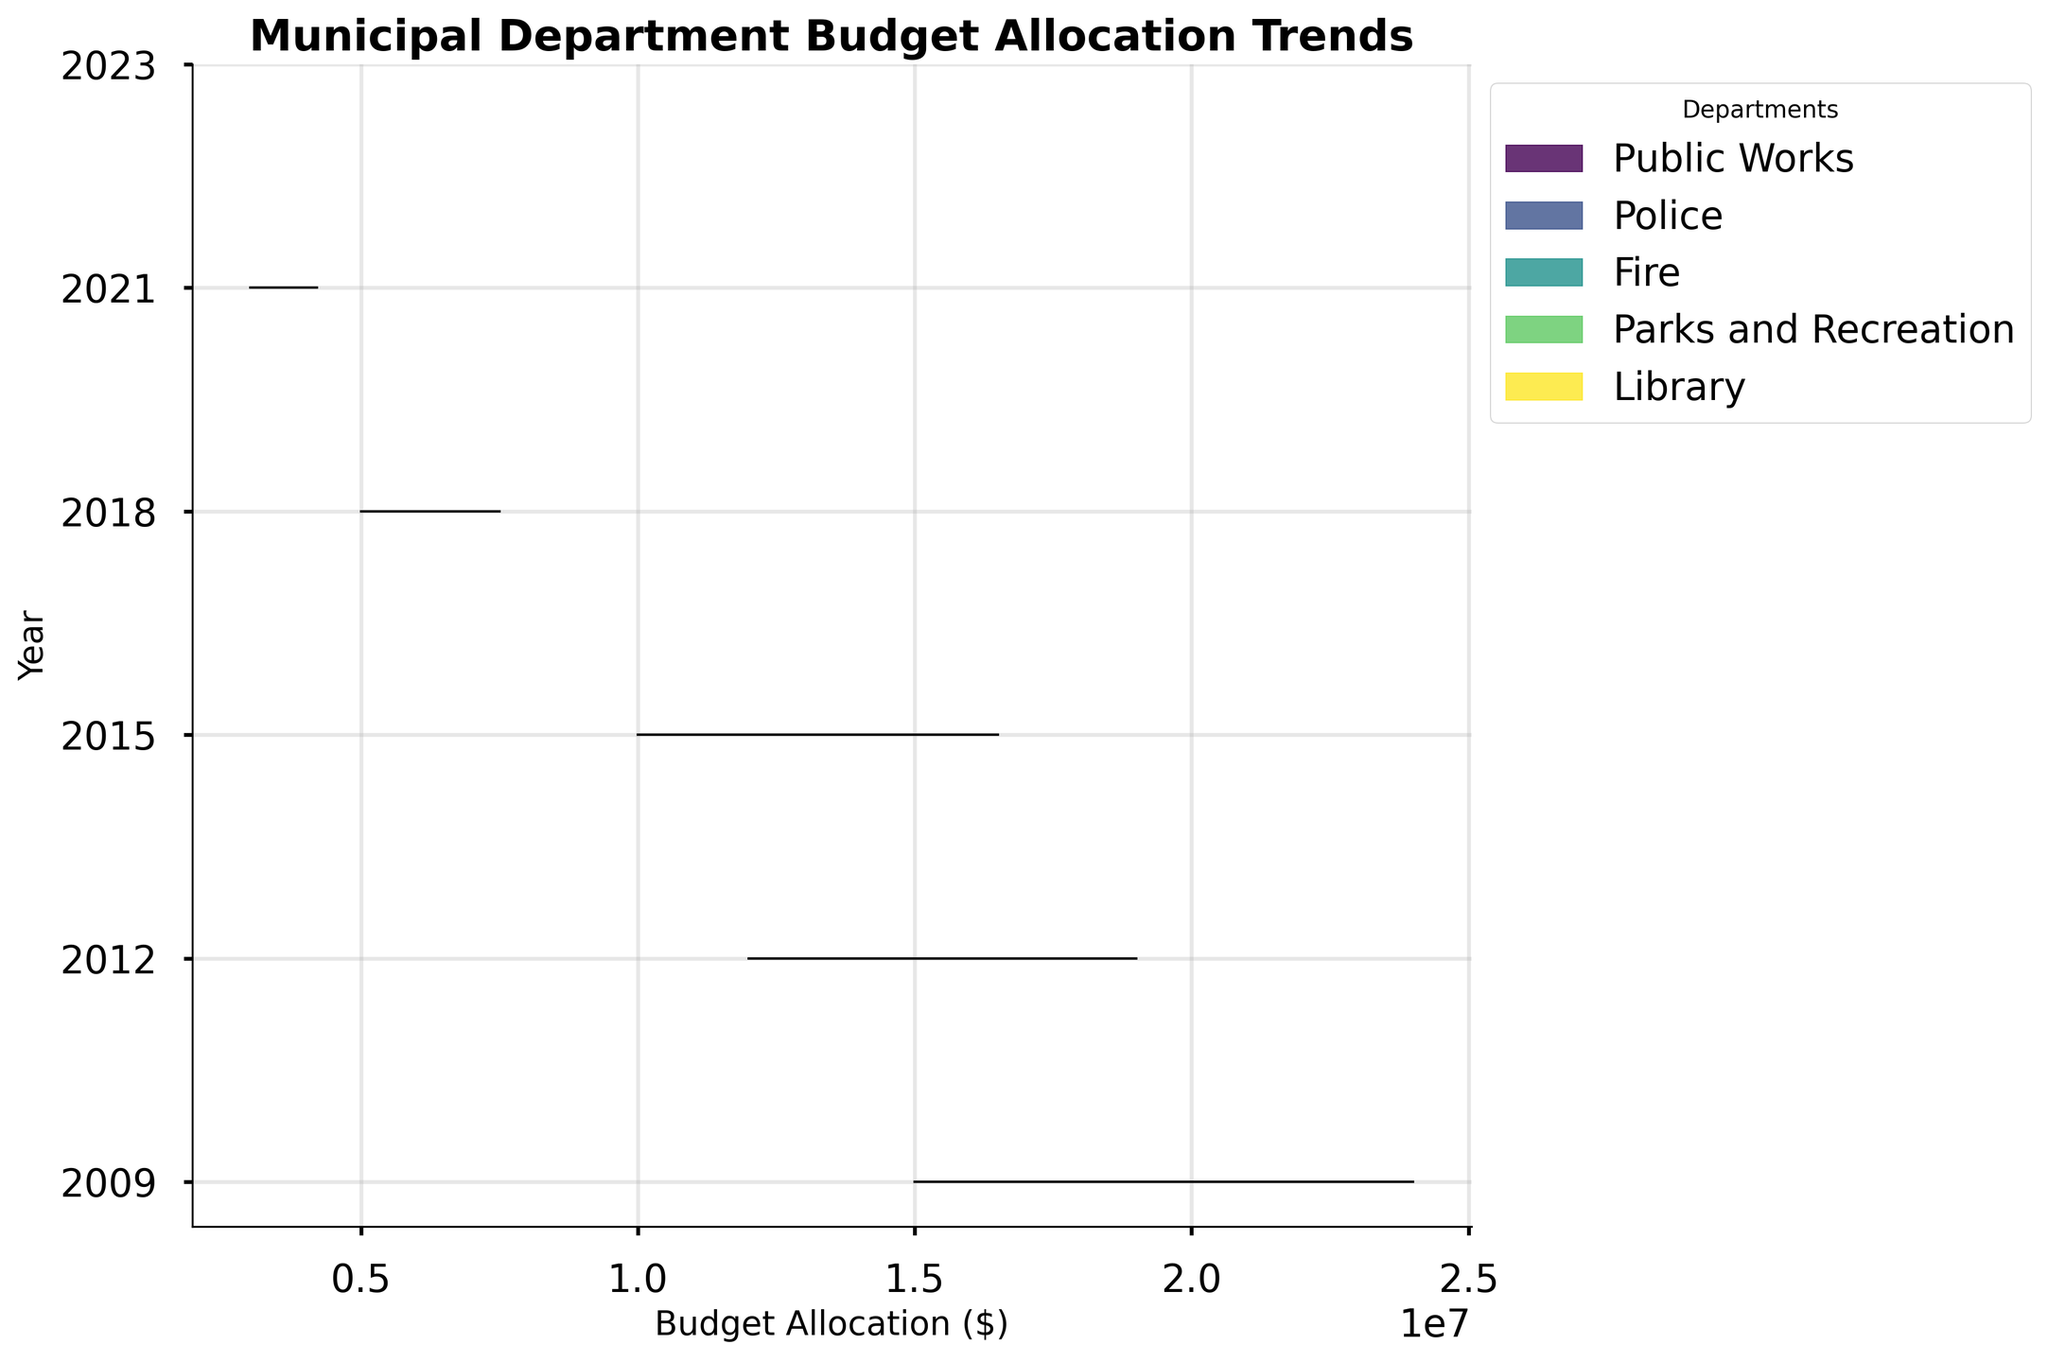What's the title of the figure? The title is usually found at the top of the plot, summarizing what the figure represents. By looking at the top of the figure, we can see the text displayed.
Answer: Municipal Department Budget Allocation Trends What do the colors in the plot represent? In ridgeline plots, colors are used to differentiate between different categories or groups. By checking the legend located typically on the side, we can see that colors represent various departments.
Answer: Different municipal departments Which department had the highest budget allocation in 2023? By examining the 2023 line and finding the peak value among the different colors representing each department, we can identify the department with the highest budget allocation.
Answer: Public Works Have any departments increased their budget allocation consistently over all years? Observing the trend lines for each department over the years, if a department's budget line never decreases but always increases or stays the same, it shows consistent growth.
Answer: Yes, Public Works Which department showed the least amount of change in budget allocation over the years? To find this, visually compare the peak variances for each department from one year to the next. The department with the smallest difference between its lowest and highest values over all years has the least change.
Answer: Library How does the budget allocation for Police in 2021 compare to that in 2015? Locate the Police department in the legend, then trace the peaks corresponding to 2015 and 2021 for the Police budget in the plot. Compare the height of the peaks.
Answer: It increased from 14500000 to 17500000 What is the general trend of budget allocation for the Fire department? Look at the peaks of the Fire department across all years. Observing their relative heights, we can discern whether they are generally rising, falling, or stable.
Answer: Increasing Which year had the smallest range of budget allocations across all departments? For each year, visually measure the distance between the lowest and highest budget allocation peaks. The year with the smallest visual distance has the smallest range.
Answer: 2009 What is the trend difference between Parks and Recreation and Library from 2015 to 2023? Compare the change in peaks for Parks and Recreation and Library between the years 2015 and 2023. Identify whether each increased, decreased, or remained stable and note the differences.
Answer: Parks and Recreation increased more than Library Is there any department whose budget allocation decreased in any year within the given period? Check the peaks for each department across all years. If we find any department where a peak is lower in a subsequent year compared to the previous year, then yes, otherwise no.
Answer: No 